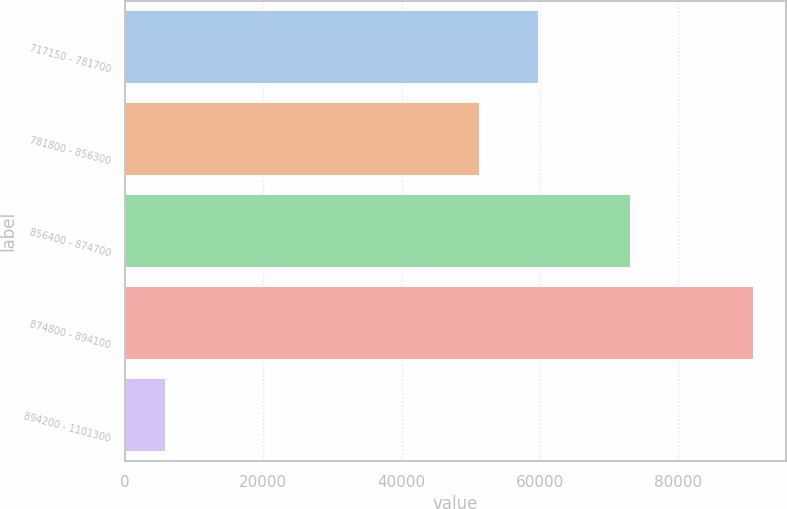Convert chart. <chart><loc_0><loc_0><loc_500><loc_500><bar_chart><fcel>717150 - 781700<fcel>781800 - 856300<fcel>856400 - 874700<fcel>874800 - 894100<fcel>894200 - 1101300<nl><fcel>59804.6<fcel>51300<fcel>73140<fcel>91000<fcel>5954<nl></chart> 